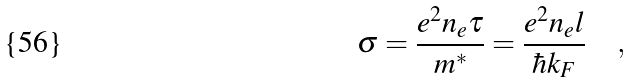Convert formula to latex. <formula><loc_0><loc_0><loc_500><loc_500>\sigma = \frac { e ^ { 2 } n _ { e } \tau } { m ^ { \ast } } = \frac { e ^ { 2 } n _ { e } l } { \hbar { k } _ { F } } \quad ,</formula> 